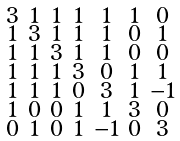Convert formula to latex. <formula><loc_0><loc_0><loc_500><loc_500>\begin{smallmatrix} 3 & 1 & 1 & 1 & 1 & 1 & 0 \\ 1 & 3 & 1 & 1 & 1 & 0 & 1 \\ 1 & 1 & 3 & 1 & 1 & 0 & 0 \\ 1 & 1 & 1 & 3 & 0 & 1 & 1 \\ 1 & 1 & 1 & 0 & 3 & 1 & - 1 \\ 1 & 0 & 0 & 1 & 1 & 3 & 0 \\ 0 & 1 & 0 & 1 & - 1 & 0 & 3 \end{smallmatrix}</formula> 